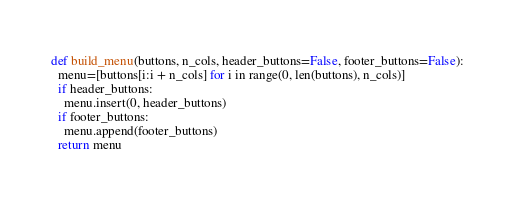Convert code to text. <code><loc_0><loc_0><loc_500><loc_500><_Python_>def build_menu(buttons, n_cols, header_buttons=False, footer_buttons=False):
  menu=[buttons[i:i + n_cols] for i in range(0, len(buttons), n_cols)]
  if header_buttons:
    menu.insert(0, header_buttons)
  if footer_buttons:
    menu.append(footer_buttons)
  return menu</code> 